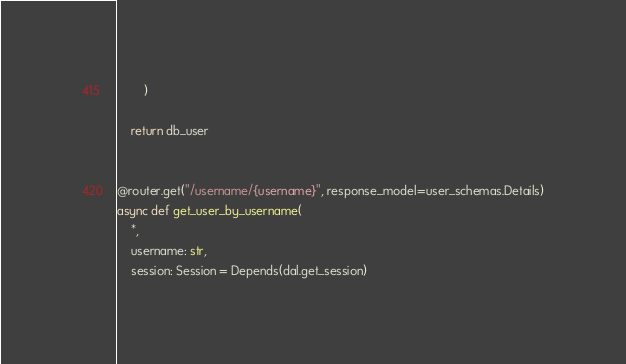<code> <loc_0><loc_0><loc_500><loc_500><_Python_>        )

    return db_user


@router.get("/username/{username}", response_model=user_schemas.Details)
async def get_user_by_username(
    *,
    username: str,
    session: Session = Depends(dal.get_session)</code> 